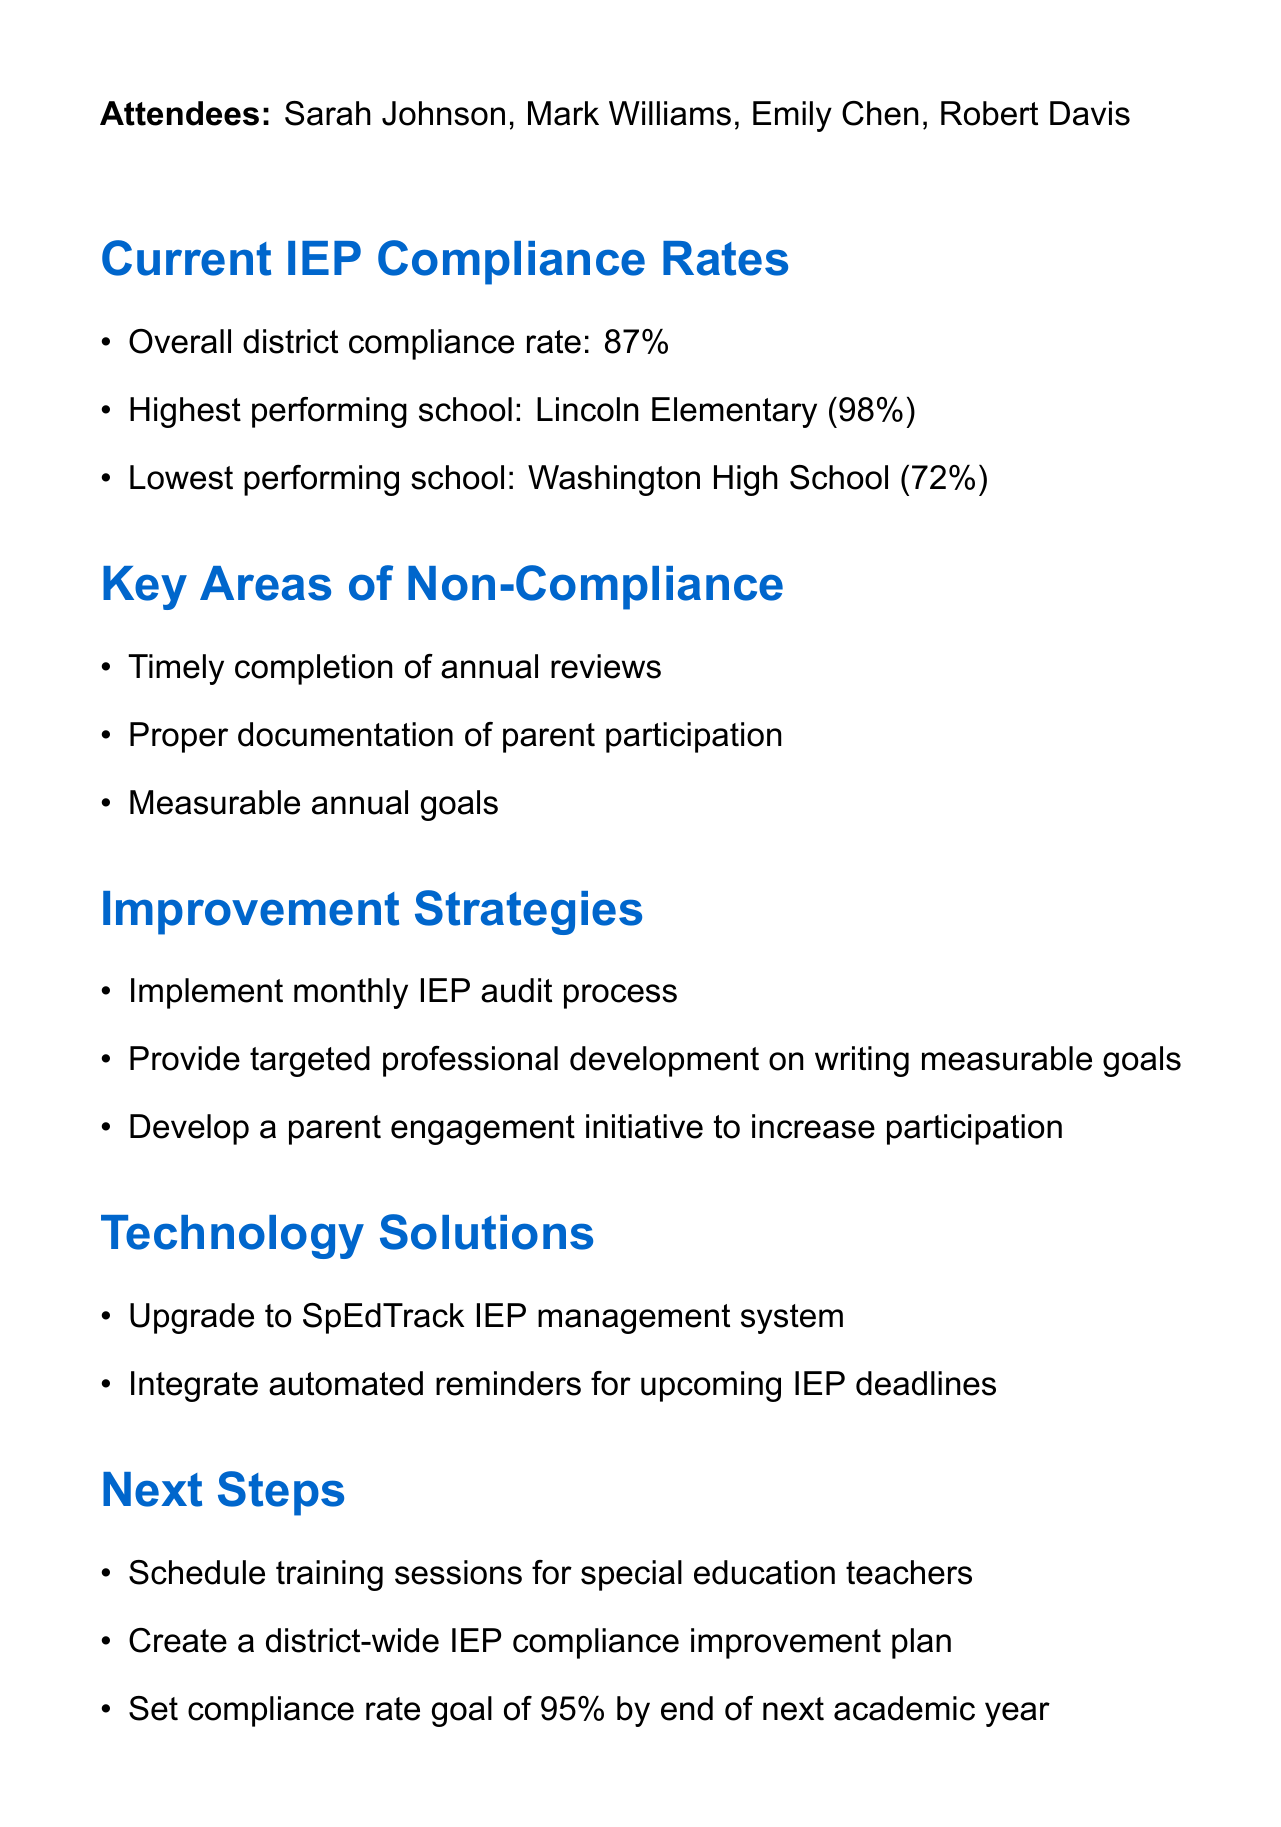What is the overall district compliance rate? The overall district compliance rate is mentioned in the meeting minutes as a specific percentage, which is 87%.
Answer: 87% Which school had the highest compliance rate? The details specify that Lincoln Elementary had the highest compliance rate at 98%.
Answer: Lincoln Elementary What is one key area of non-compliance? The document lists specific areas of non-compliance, one of which is timely completion of annual reviews.
Answer: Timely completion of annual reviews What is one strategy for improvement? The meeting minutes provide several strategies, one of which is to implement a monthly IEP audit process.
Answer: Implement monthly IEP audit process What system is proposed for upgrade? The minutes indicate that the district plans to upgrade to the SpEdTrack IEP management system.
Answer: SpEdTrack IEP management system What is the compliance rate goal by the end of the next academic year? A specific goal is set for compliance rates in the minutes, which is a target of 95% by the end of the next academic year.
Answer: 95% Who is assigned to develop the professional development schedule? The minutes specify that Sarah Johnson is responsible for developing the professional development schedule.
Answer: Sarah Johnson When is the due date for initiating the SpEdTrack system upgrade? The action items include a due date for this task, which is July 15, 2023.
Answer: July 15, 2023 